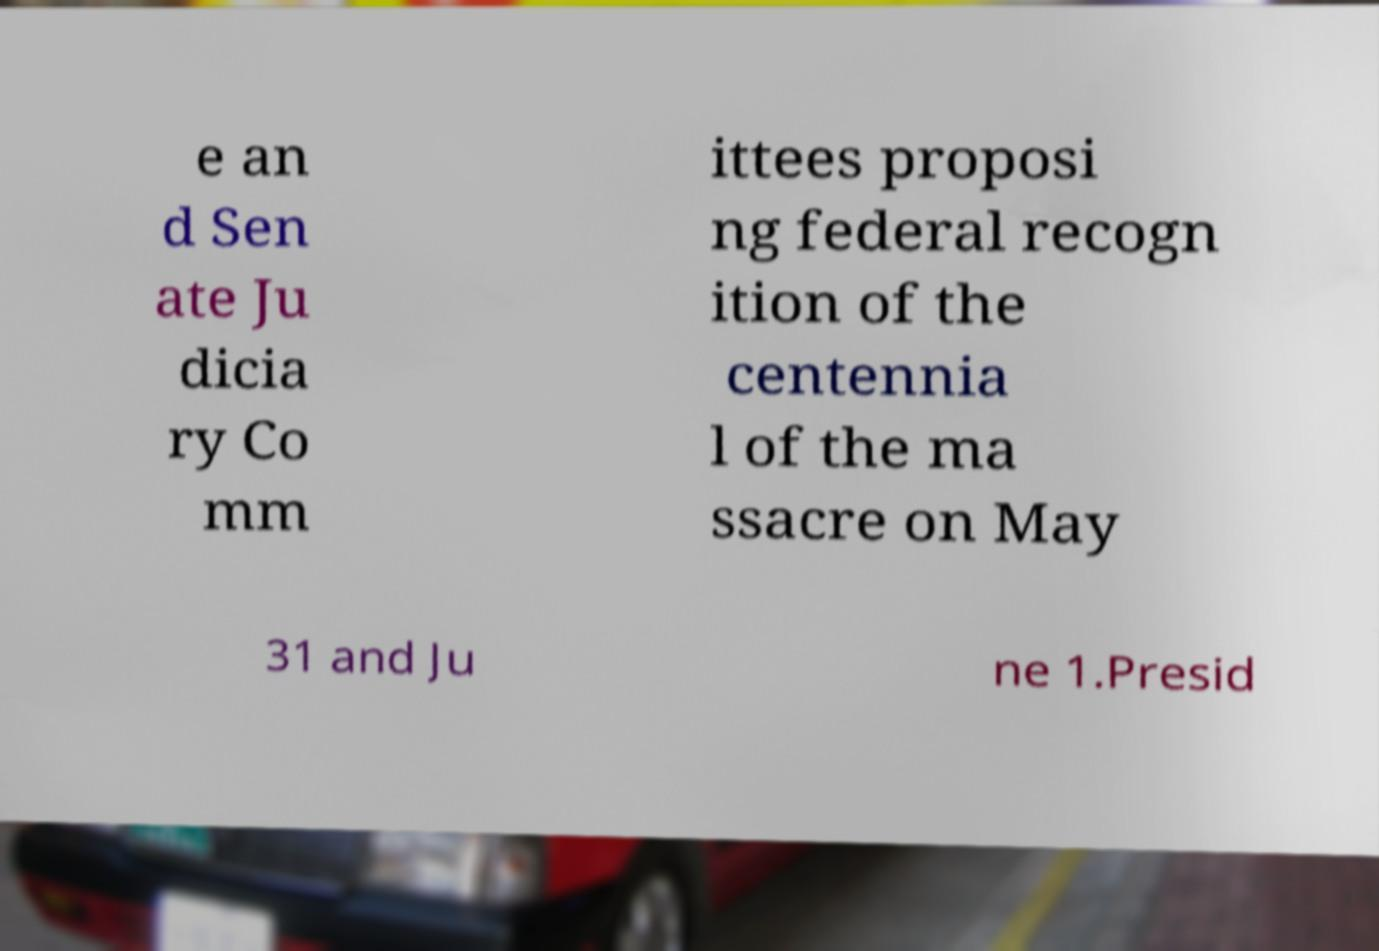Please read and relay the text visible in this image. What does it say? e an d Sen ate Ju dicia ry Co mm ittees proposi ng federal recogn ition of the centennia l of the ma ssacre on May 31 and Ju ne 1.Presid 